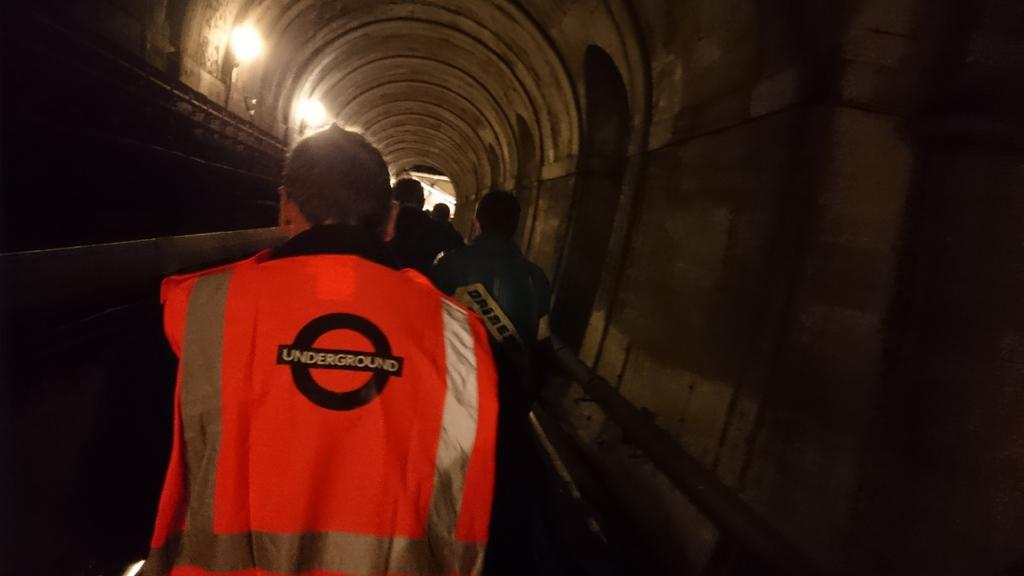Who or what is present in the image? There are people in the image. What are the people wearing? The people are wearing clothes. What can be seen in the background of the image? There is a wall in the image. Is there any source of light visible in the image? Yes, there is a light in the image. How many quarters and dimes are visible on the cushion in the image? There is no cushion or currency present in the image. 